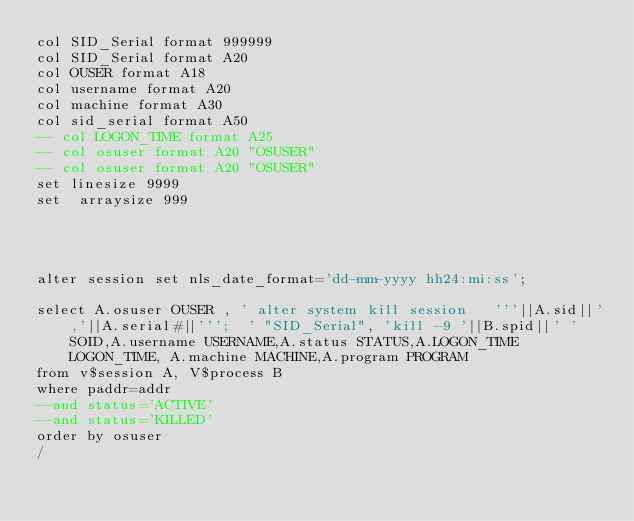Convert code to text. <code><loc_0><loc_0><loc_500><loc_500><_SQL_>col SID_Serial format 999999
col SID_Serial format A20
col OUSER format A18 
col username format A20
col machine format A30 
col sid_serial format A50
-- col LOGON_TIME format A25
-- col osuser format A20 "OSUSER"
-- col osuser format A20 "OSUSER"
set linesize 9999
set  arraysize 999




alter session set nls_date_format='dd-mm-yyyy hh24:mi:ss';

select A.osuser OUSER , ' alter system kill session   '''||A.sid||','||A.serial#||''';  ' "SID_Serial", 'kill -9 '||B.spid||' '  SOID,A.username USERNAME,A.status STATUS,A.LOGON_TIME LOGON_TIME, A.machine MACHINE,A.program PROGRAM
from v$session A, V$process B
where paddr=addr
--and status='ACTIVE'
--and status='KILLED'
order by osuser
/



</code> 